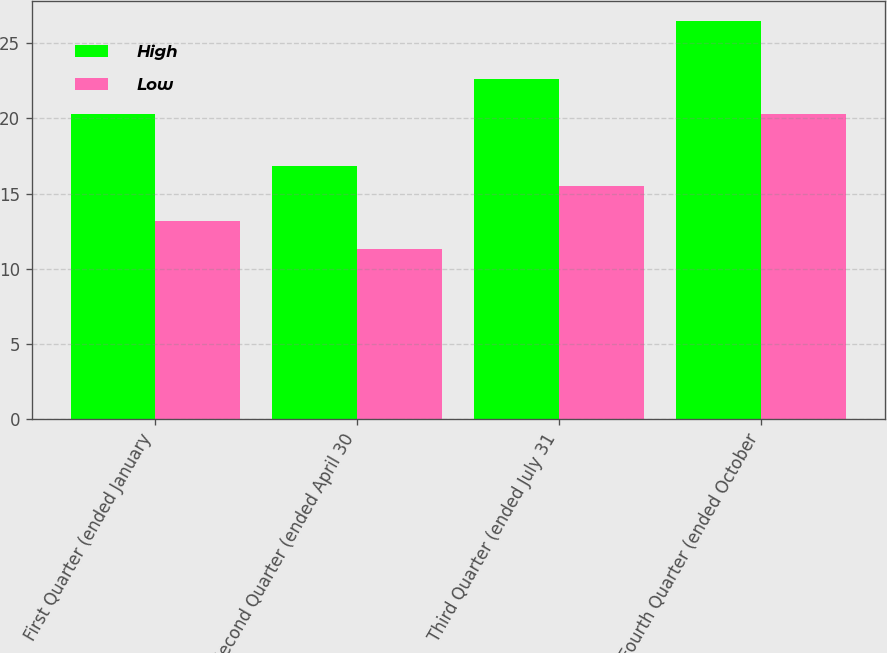Convert chart to OTSL. <chart><loc_0><loc_0><loc_500><loc_500><stacked_bar_chart><ecel><fcel>First Quarter (ended January<fcel>Second Quarter (ended April 30<fcel>Third Quarter (ended July 31<fcel>Fourth Quarter (ended October<nl><fcel>High<fcel>20.3<fcel>16.82<fcel>22.64<fcel>26.48<nl><fcel>Low<fcel>13.19<fcel>11.3<fcel>15.48<fcel>20.31<nl></chart> 